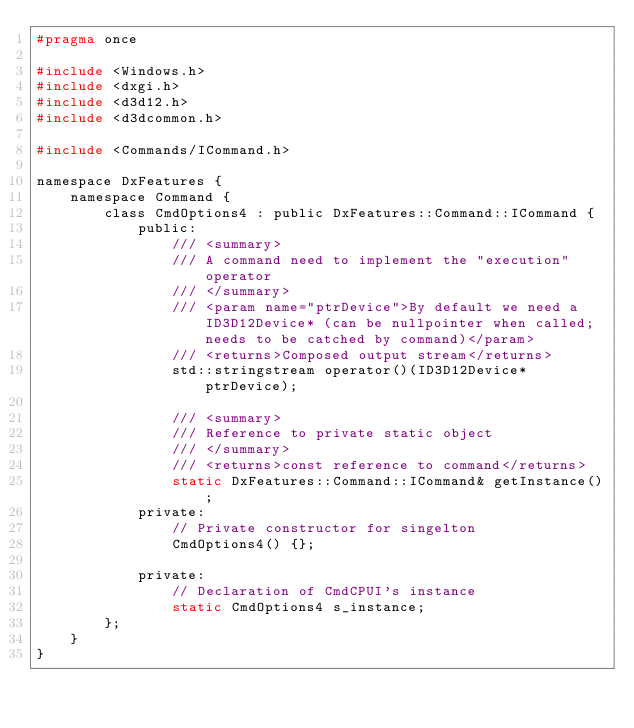Convert code to text. <code><loc_0><loc_0><loc_500><loc_500><_C_>#pragma once

#include <Windows.h>
#include <dxgi.h>
#include <d3d12.h>
#include <d3dcommon.h>

#include <Commands/ICommand.h>

namespace DxFeatures {
	namespace Command {
		class CmdOptions4 : public DxFeatures::Command::ICommand {
			public:
				/// <summary>
				/// A command need to implement the "execution" operator
				/// </summary>
				/// <param name="ptrDevice">By default we need a ID3D12Device* (can be nullpointer when called; needs to be catched by command)</param>
				/// <returns>Composed output stream</returns>
				std::stringstream operator()(ID3D12Device* ptrDevice);

				/// <summary>
				/// Reference to private static object
				/// </summary>
				/// <returns>const reference to command</returns>
				static DxFeatures::Command::ICommand& getInstance();
			private:
				// Private constructor for singelton
				CmdOptions4() {};

			private:
				// Declaration of CmdCPUI's instance 
				static CmdOptions4 s_instance;
		};
	}
}</code> 